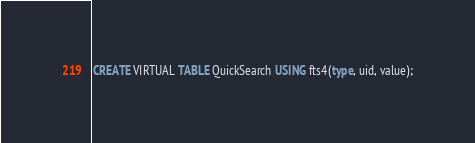Convert code to text. <code><loc_0><loc_0><loc_500><loc_500><_SQL_>CREATE VIRTUAL TABLE QuickSearch USING fts4(type, uid, value);</code> 